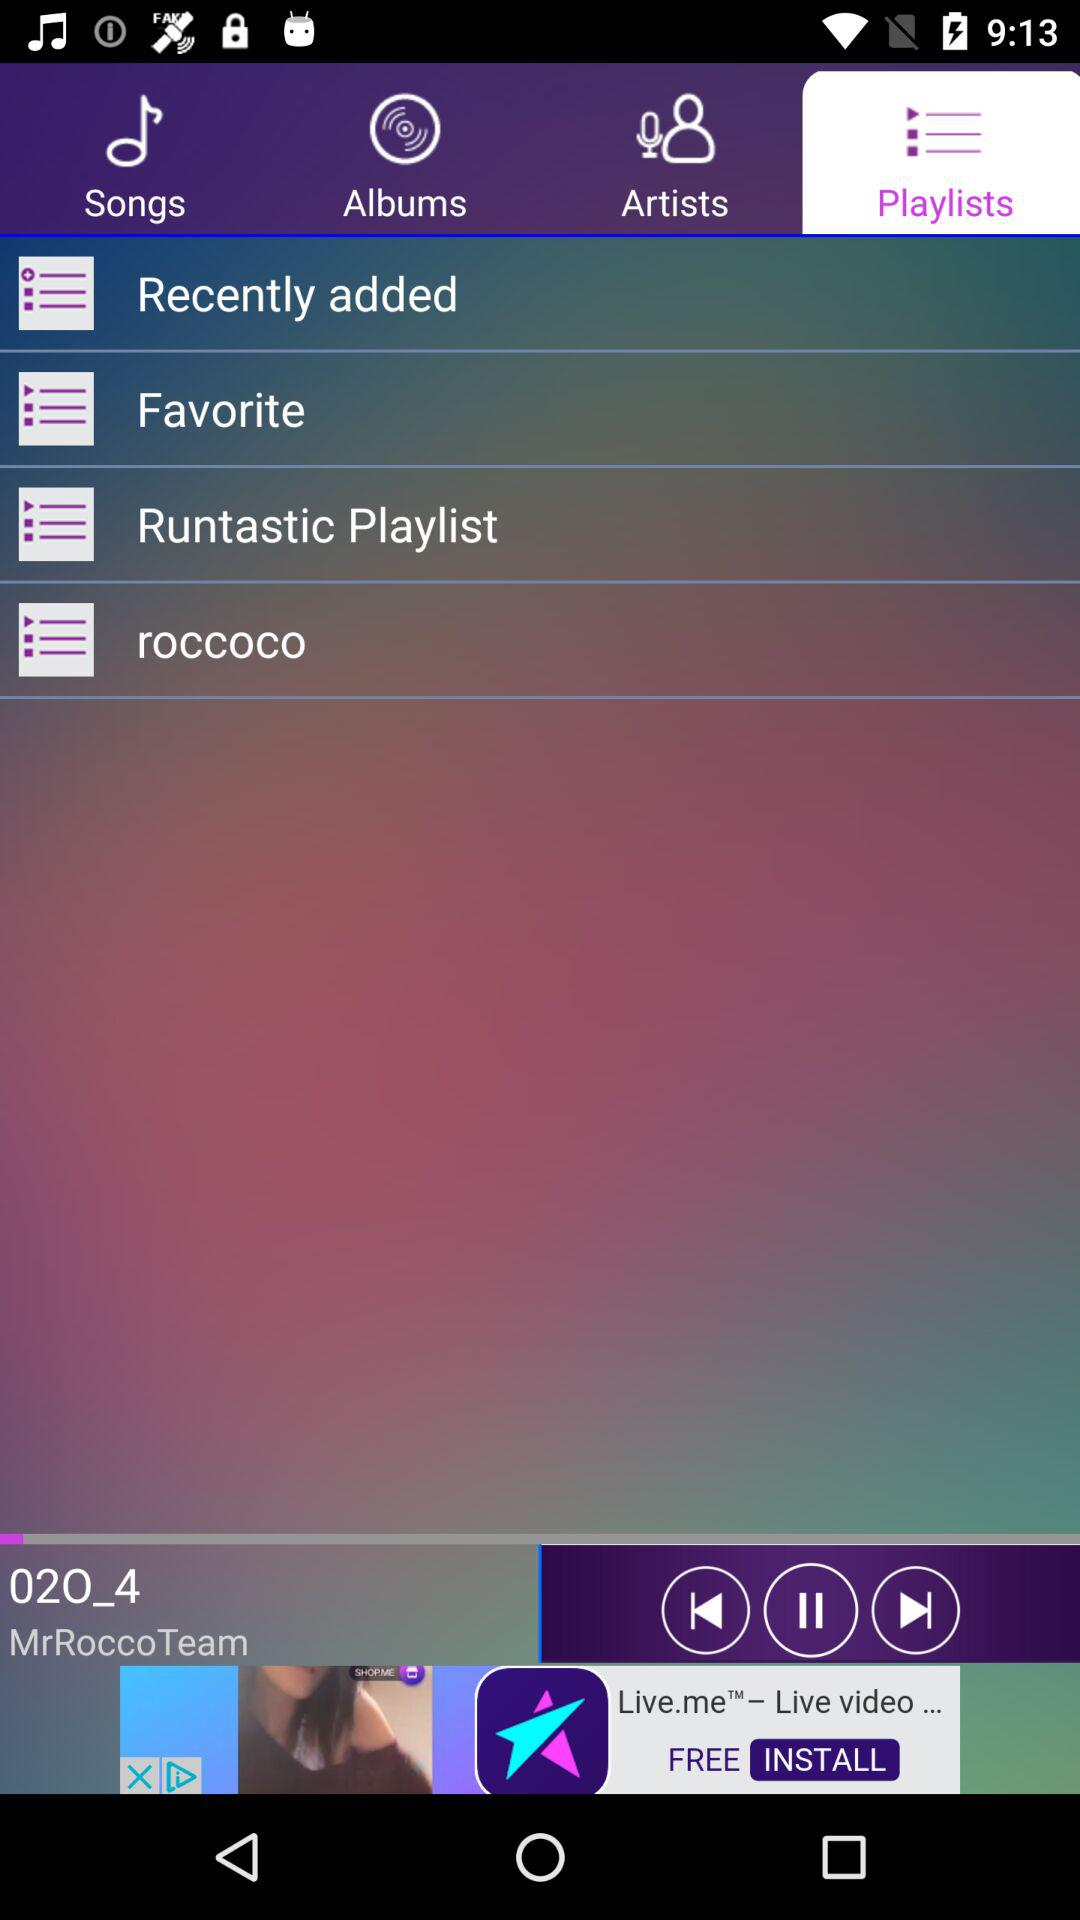Which option is selected? The selected option is "Playlists". 